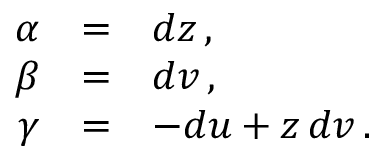<formula> <loc_0><loc_0><loc_500><loc_500>\begin{array} { r c l } { \alpha } & { = } & { d z \, , } \\ { \beta } & { = } & { d v \, , } \\ { \gamma } & { = } & { - d u + z \, d v \, . } \end{array}</formula> 